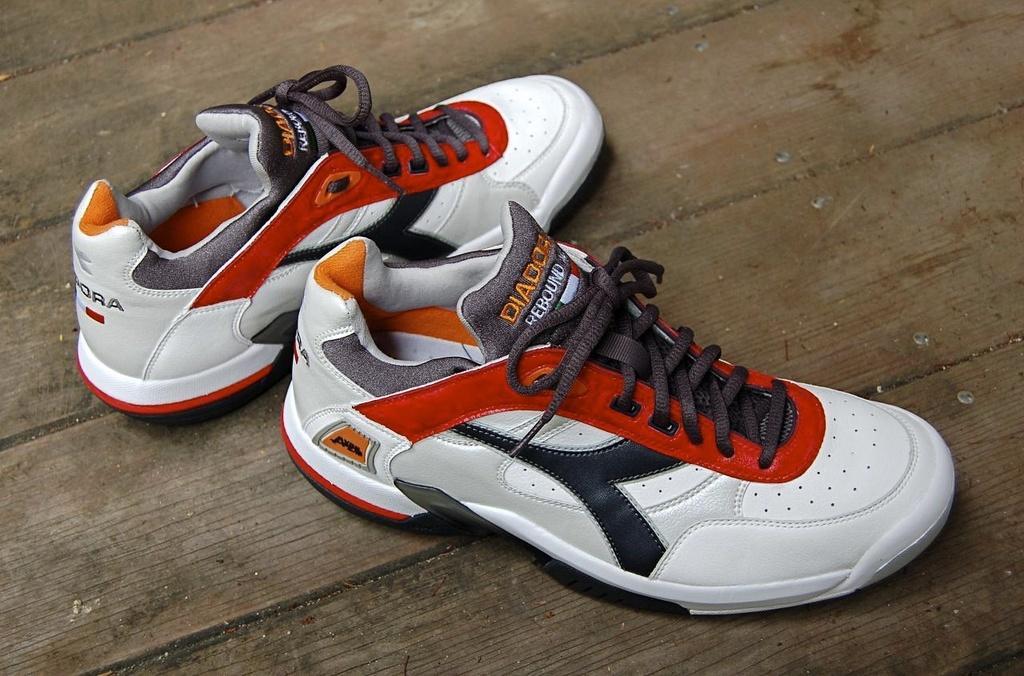Can you describe this image briefly? Here we can see a pair of shoes on a platform. 